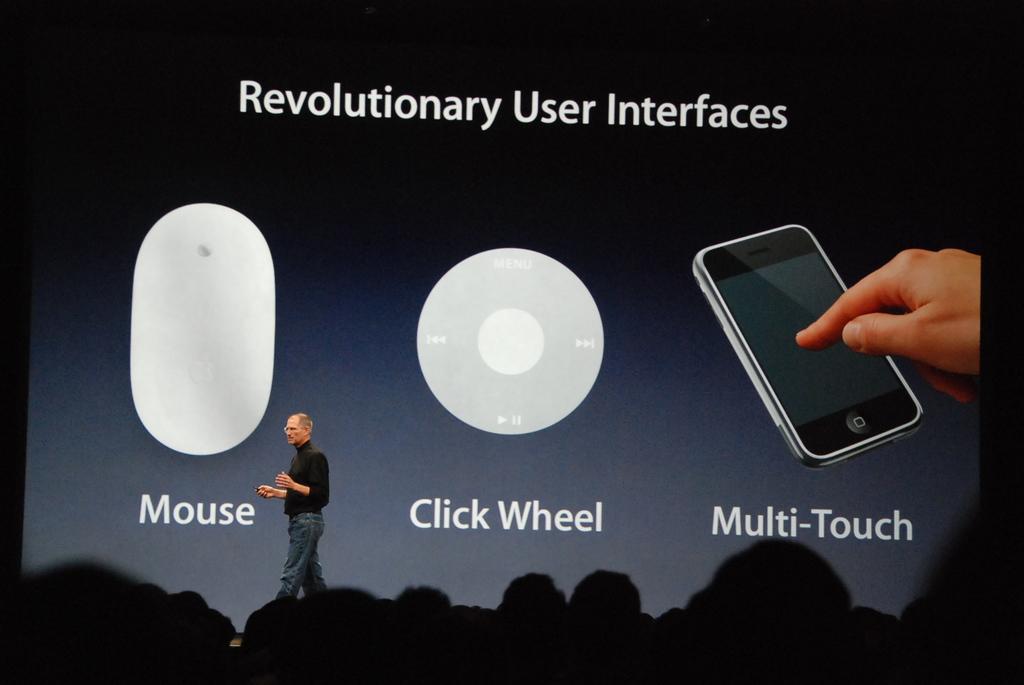What is steve jobs talking about?
Give a very brief answer. Revolutionary user interfaces. Who is the man in the picture?
Provide a succinct answer. Answering does not require reading text in the image. 